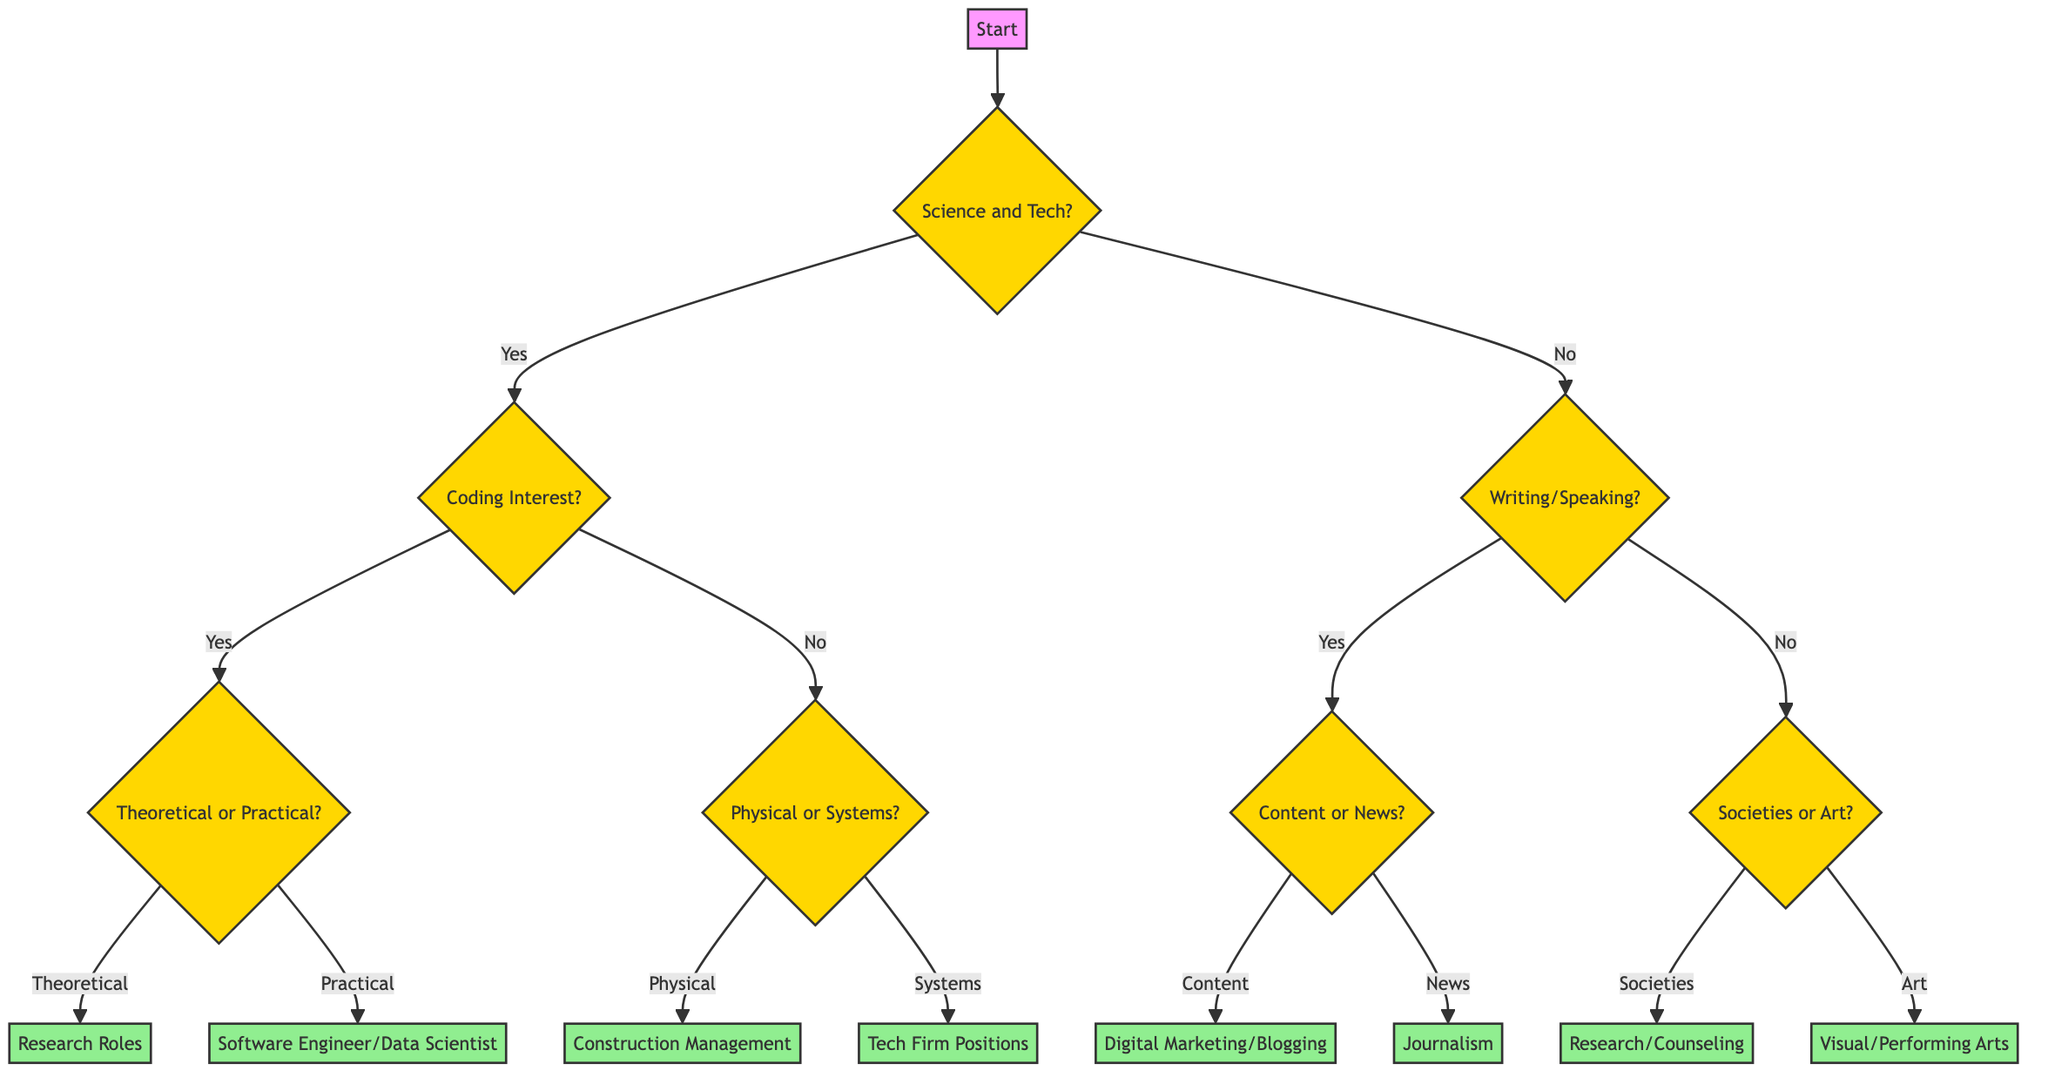What is the first question in the decision tree? The first question asked in the decision tree is about having a passion for science and technology. This question guides the entire flow of the tree.
Answer: Do you have a passion for science and technology? How many major branches are there in the decision tree? The decision tree splits into two major branches based on the first question: "Science and Tech" and "Humanities and Arts." Thus, there are two major branches.
Answer: 2 What career options follow if the answer to "Are you more interested in coding and software development?" is 'no'? If the response to this question is 'no', the decision tree suggests pursuing Engineering, which subsequently leads to further questions about physical structures or designing systems.
Answer: Engineering What will be the outcome if the answer to "Do you prefer creating content or reporting news?" is 'yes'? A 'yes' response to this question leads to the next consideration about content creation, specifically resulting in career options in Digital Marketing or Blogging.
Answer: Digital Marketing or Blogging If someone answered 'no' to both "Do you have a passion for science and technology?" and "Do you enjoy expressing yourself through writing or speaking?", what is the resulting option? For this pathway, the decision tree leads to Fine Arts, as it is the outcome of the 'no' answers at the respective junctions for the Humanities and Arts branch.
Answer: Fine Arts What type of roles would one aim for if they choose Computer Science and prefer practical applications? If Computer Science is chosen and practical applications are preferred, the decision tree suggests aiming for roles as a Software Engineer or Data Scientist.
Answer: Software Engineer or Data Scientist What question follows directly after choosing Engineering? The question that follows after deciding on Engineering asks if the individual is inclined toward building physical structures or designing systems, determining the path within Engineering.
Answer: Are you inclined towards building physical structures or designing systems? What can be inferred if someone reaches the "Sociology, Psychology" outcome? Reaching the outcome of Sociology or Psychology indicates that the individual has shown interest in understanding societies within the Humanities and Arts branch, specifically after confirming a preference for Social Sciences.
Answer: Understanding societies 